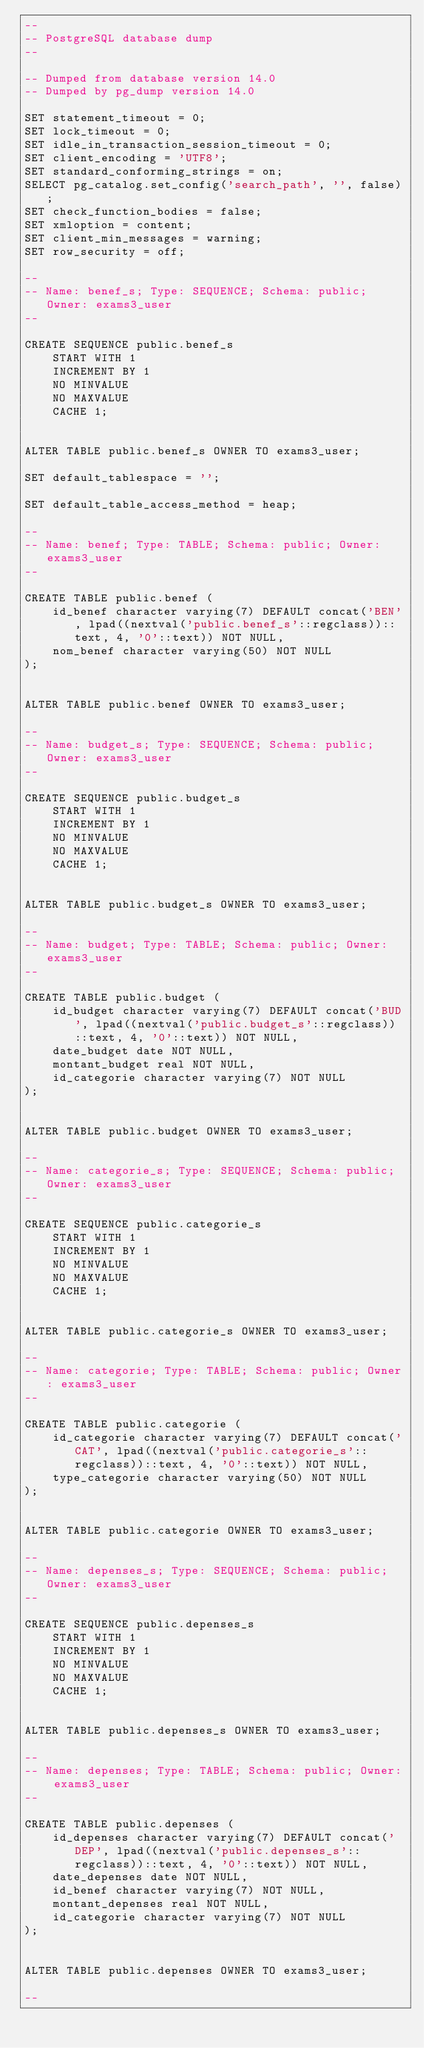Convert code to text. <code><loc_0><loc_0><loc_500><loc_500><_SQL_>--
-- PostgreSQL database dump
--

-- Dumped from database version 14.0
-- Dumped by pg_dump version 14.0

SET statement_timeout = 0;
SET lock_timeout = 0;
SET idle_in_transaction_session_timeout = 0;
SET client_encoding = 'UTF8';
SET standard_conforming_strings = on;
SELECT pg_catalog.set_config('search_path', '', false);
SET check_function_bodies = false;
SET xmloption = content;
SET client_min_messages = warning;
SET row_security = off;

--
-- Name: benef_s; Type: SEQUENCE; Schema: public; Owner: exams3_user
--

CREATE SEQUENCE public.benef_s
    START WITH 1
    INCREMENT BY 1
    NO MINVALUE
    NO MAXVALUE
    CACHE 1;


ALTER TABLE public.benef_s OWNER TO exams3_user;

SET default_tablespace = '';

SET default_table_access_method = heap;

--
-- Name: benef; Type: TABLE; Schema: public; Owner: exams3_user
--

CREATE TABLE public.benef (
    id_benef character varying(7) DEFAULT concat('BEN', lpad((nextval('public.benef_s'::regclass))::text, 4, '0'::text)) NOT NULL,
    nom_benef character varying(50) NOT NULL
);


ALTER TABLE public.benef OWNER TO exams3_user;

--
-- Name: budget_s; Type: SEQUENCE; Schema: public; Owner: exams3_user
--

CREATE SEQUENCE public.budget_s
    START WITH 1
    INCREMENT BY 1
    NO MINVALUE
    NO MAXVALUE
    CACHE 1;


ALTER TABLE public.budget_s OWNER TO exams3_user;

--
-- Name: budget; Type: TABLE; Schema: public; Owner: exams3_user
--

CREATE TABLE public.budget (
    id_budget character varying(7) DEFAULT concat('BUD', lpad((nextval('public.budget_s'::regclass))::text, 4, '0'::text)) NOT NULL,
    date_budget date NOT NULL,
    montant_budget real NOT NULL,
    id_categorie character varying(7) NOT NULL
);


ALTER TABLE public.budget OWNER TO exams3_user;

--
-- Name: categorie_s; Type: SEQUENCE; Schema: public; Owner: exams3_user
--

CREATE SEQUENCE public.categorie_s
    START WITH 1
    INCREMENT BY 1
    NO MINVALUE
    NO MAXVALUE
    CACHE 1;


ALTER TABLE public.categorie_s OWNER TO exams3_user;

--
-- Name: categorie; Type: TABLE; Schema: public; Owner: exams3_user
--

CREATE TABLE public.categorie (
    id_categorie character varying(7) DEFAULT concat('CAT', lpad((nextval('public.categorie_s'::regclass))::text, 4, '0'::text)) NOT NULL,
    type_categorie character varying(50) NOT NULL
);


ALTER TABLE public.categorie OWNER TO exams3_user;

--
-- Name: depenses_s; Type: SEQUENCE; Schema: public; Owner: exams3_user
--

CREATE SEQUENCE public.depenses_s
    START WITH 1
    INCREMENT BY 1
    NO MINVALUE
    NO MAXVALUE
    CACHE 1;


ALTER TABLE public.depenses_s OWNER TO exams3_user;

--
-- Name: depenses; Type: TABLE; Schema: public; Owner: exams3_user
--

CREATE TABLE public.depenses (
    id_depenses character varying(7) DEFAULT concat('DEP', lpad((nextval('public.depenses_s'::regclass))::text, 4, '0'::text)) NOT NULL,
    date_depenses date NOT NULL,
    id_benef character varying(7) NOT NULL,
    montant_depenses real NOT NULL,
    id_categorie character varying(7) NOT NULL
);


ALTER TABLE public.depenses OWNER TO exams3_user;

--</code> 